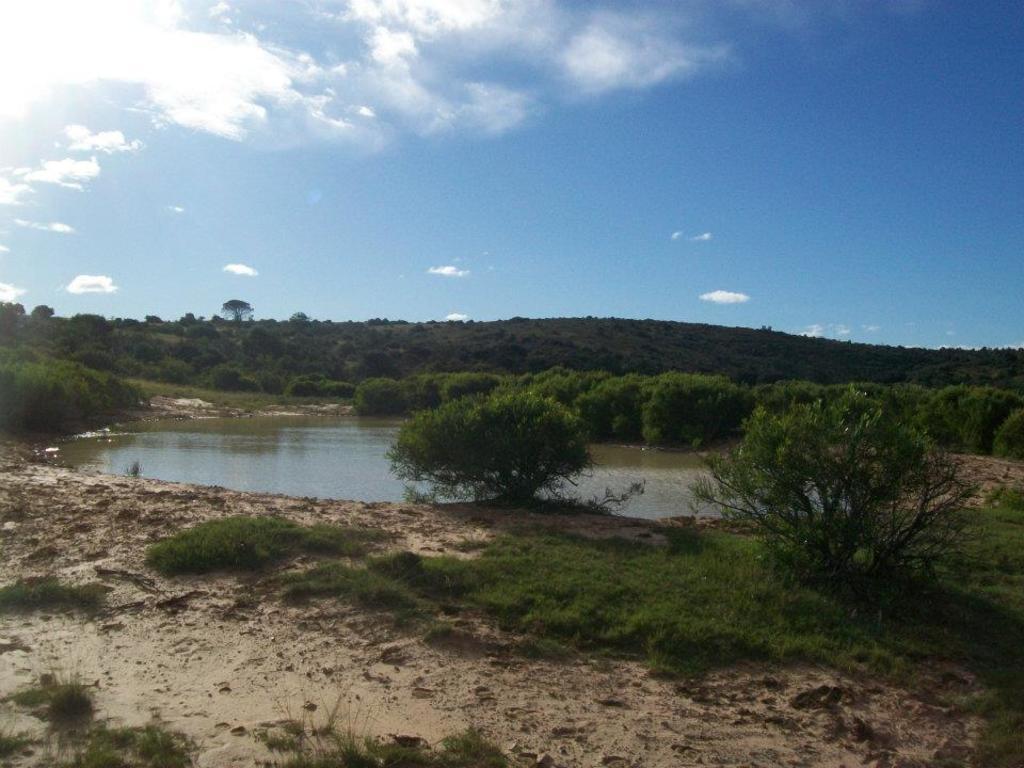Please provide a concise description of this image. In this image, we can see trees and there is a hill. At the bottom, there is water and ground covered with grass. At the top, there are clouds in the sky. 